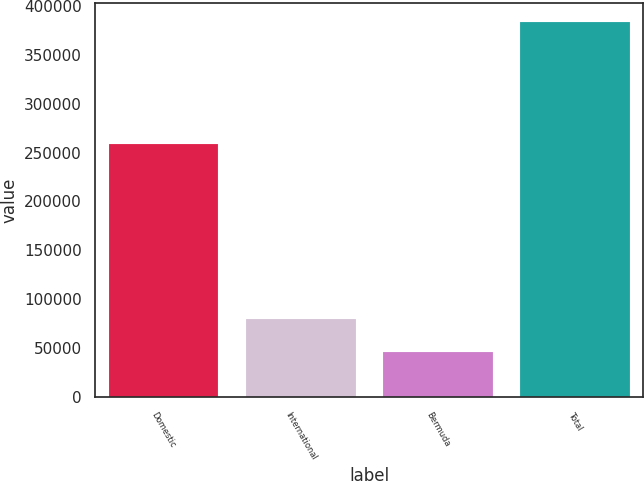Convert chart. <chart><loc_0><loc_0><loc_500><loc_500><bar_chart><fcel>Domestic<fcel>International<fcel>Bermuda<fcel>Total<nl><fcel>258688<fcel>79503.3<fcel>45696<fcel>383769<nl></chart> 